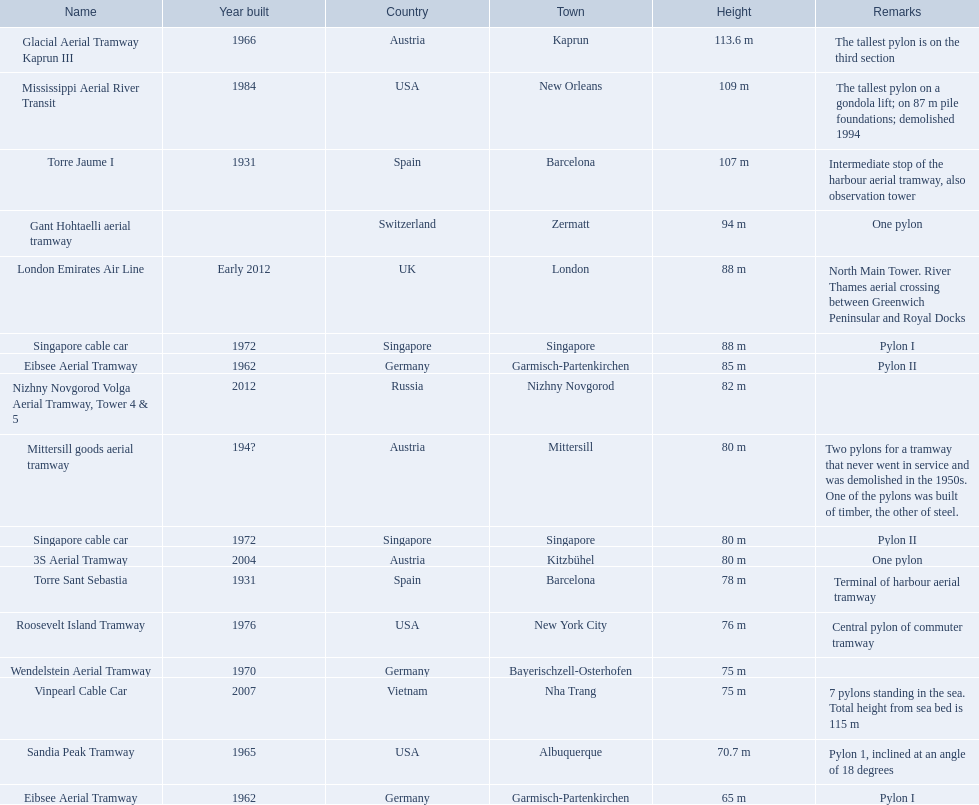How many aerial lift towers on the list are situated in the usa? Mississippi Aerial River Transit, Roosevelt Island Tramway, Sandia Peak Tramway. Of the towers situated in the usa, how many were constructed after 1970? Mississippi Aerial River Transit, Roosevelt Island Tramway. Of the towers constructed after 1970, which is the highest tower on a gondola lift? Mississippi Aerial River Transit. How many meters is the highest tower on a gondola lift? 109 m. 